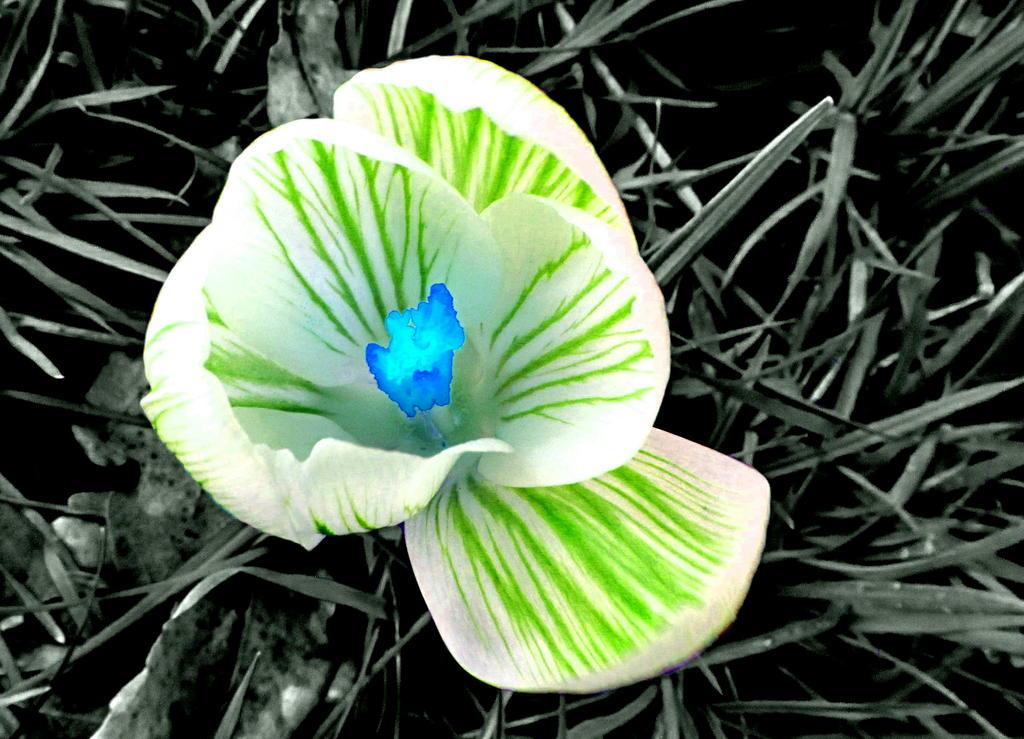What is the nature of the image? The image appears to be edited. What type of plant can be seen in the image? There is a flower in the image. What type of vegetation is visible behind the flower? There is grass visible in the image behind the flower. What type of ring can be seen on the flower in the image? There is no ring present on the flower in the image. What type of pump is visible in the image? There is no pump present in the image. 